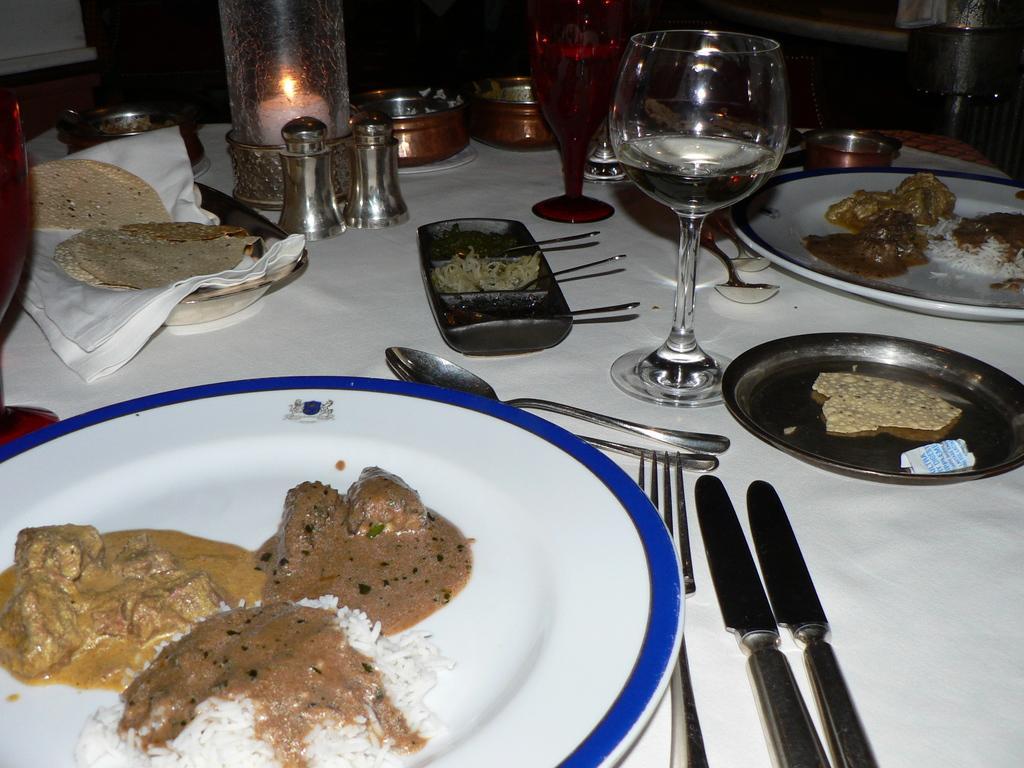How would you summarize this image in a sentence or two? In this image I can see food items on plates, there are spoons, forks, knives, glasses and some other objects on the table. 